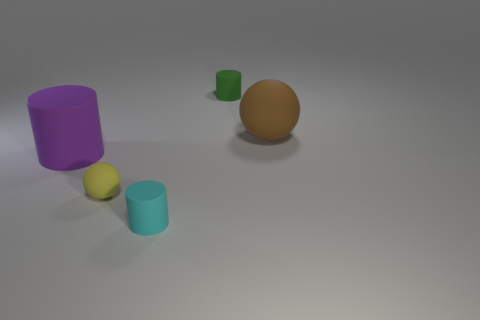What number of blocks are green things or small yellow rubber things?
Keep it short and to the point. 0. Does the small cyan object have the same shape as the big purple rubber thing?
Your answer should be compact. Yes. There is a matte cylinder left of the small cyan matte thing; what is its size?
Your answer should be compact. Large. Is there another matte cylinder of the same color as the large cylinder?
Offer a terse response. No. There is a matte ball that is to the right of the green rubber thing; does it have the same size as the tiny yellow rubber object?
Make the answer very short. No. What is the color of the large rubber cylinder?
Offer a very short reply. Purple. The thing that is behind the rubber ball that is behind the big rubber cylinder is what color?
Give a very brief answer. Green. Are there any tiny green cylinders made of the same material as the purple object?
Offer a very short reply. Yes. There is a small cylinder that is on the left side of the tiny rubber thing behind the yellow rubber object; what is it made of?
Offer a terse response. Rubber. How many tiny yellow matte objects are the same shape as the brown object?
Provide a short and direct response. 1. 